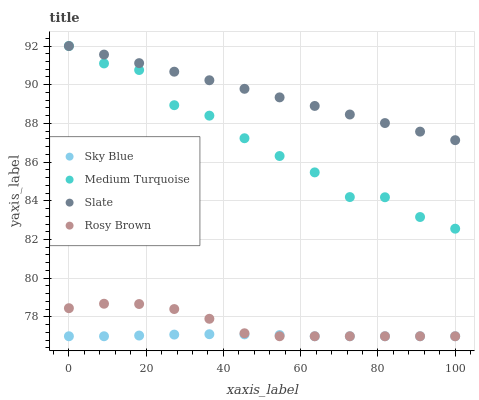Does Sky Blue have the minimum area under the curve?
Answer yes or no. Yes. Does Slate have the maximum area under the curve?
Answer yes or no. Yes. Does Rosy Brown have the minimum area under the curve?
Answer yes or no. No. Does Rosy Brown have the maximum area under the curve?
Answer yes or no. No. Is Slate the smoothest?
Answer yes or no. Yes. Is Medium Turquoise the roughest?
Answer yes or no. Yes. Is Rosy Brown the smoothest?
Answer yes or no. No. Is Rosy Brown the roughest?
Answer yes or no. No. Does Sky Blue have the lowest value?
Answer yes or no. Yes. Does Slate have the lowest value?
Answer yes or no. No. Does Medium Turquoise have the highest value?
Answer yes or no. Yes. Does Rosy Brown have the highest value?
Answer yes or no. No. Is Sky Blue less than Medium Turquoise?
Answer yes or no. Yes. Is Medium Turquoise greater than Sky Blue?
Answer yes or no. Yes. Does Rosy Brown intersect Sky Blue?
Answer yes or no. Yes. Is Rosy Brown less than Sky Blue?
Answer yes or no. No. Is Rosy Brown greater than Sky Blue?
Answer yes or no. No. Does Sky Blue intersect Medium Turquoise?
Answer yes or no. No. 